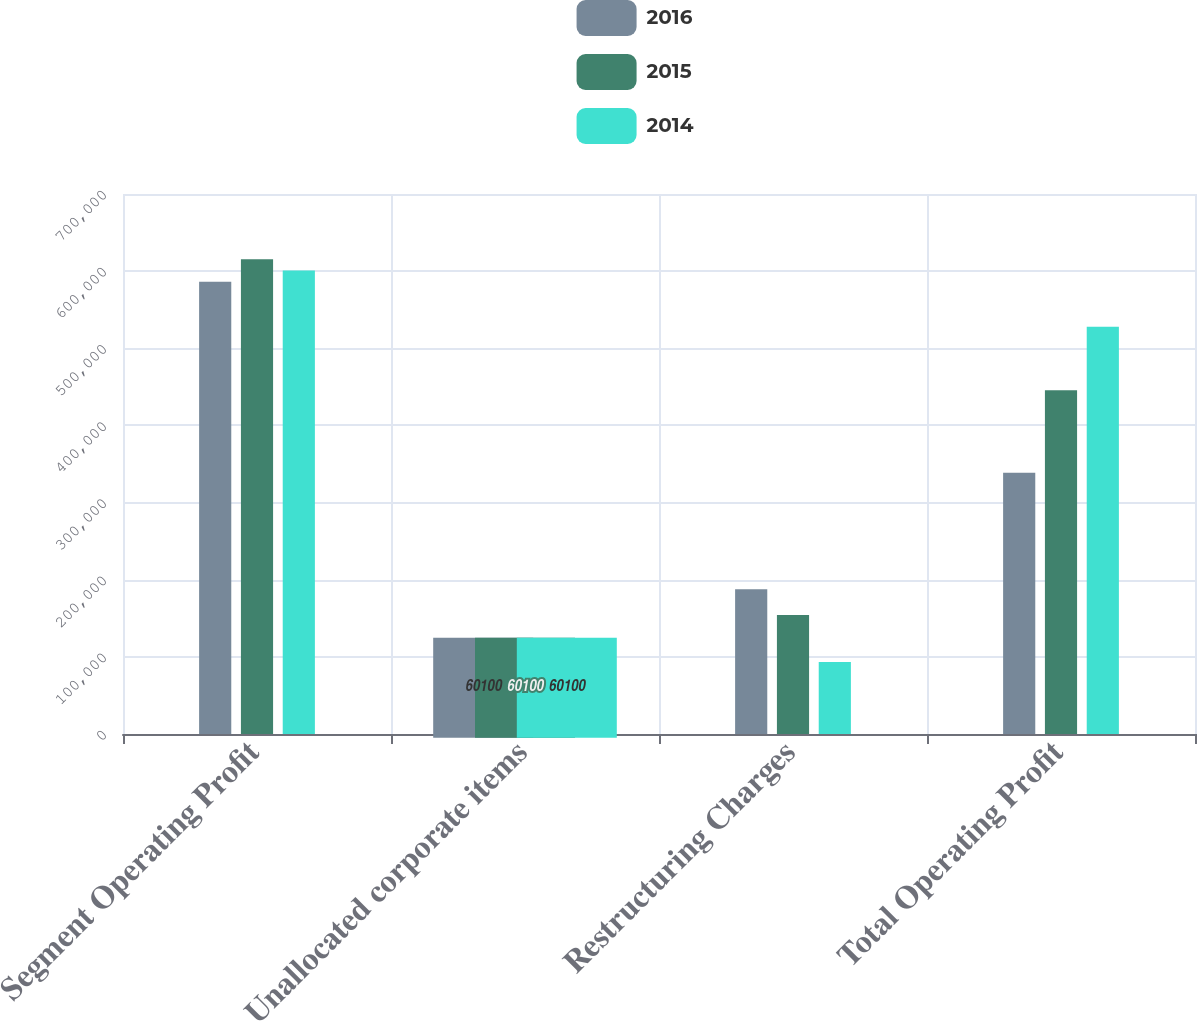Convert chart. <chart><loc_0><loc_0><loc_500><loc_500><stacked_bar_chart><ecel><fcel>Segment Operating Profit<fcel>Unallocated corporate items<fcel>Restructuring Charges<fcel>Total Operating Profit<nl><fcel>2016<fcel>586328<fcel>60100<fcel>187630<fcel>338598<nl><fcel>2015<fcel>615549<fcel>15739<fcel>154283<fcel>445527<nl><fcel>2014<fcel>600815<fcel>20583<fcel>93330<fcel>528068<nl></chart> 